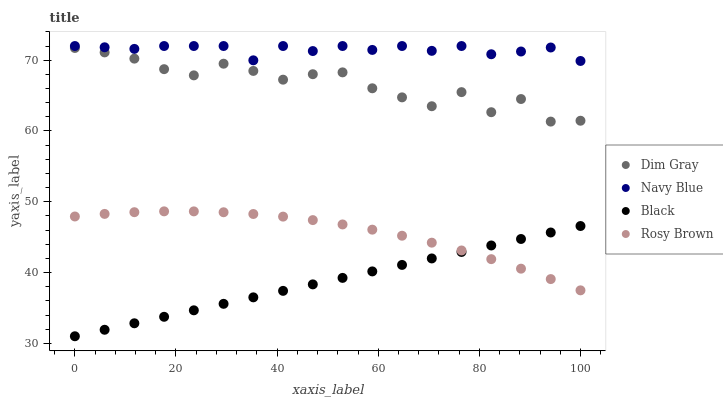Does Black have the minimum area under the curve?
Answer yes or no. Yes. Does Navy Blue have the maximum area under the curve?
Answer yes or no. Yes. Does Rosy Brown have the minimum area under the curve?
Answer yes or no. No. Does Rosy Brown have the maximum area under the curve?
Answer yes or no. No. Is Black the smoothest?
Answer yes or no. Yes. Is Dim Gray the roughest?
Answer yes or no. Yes. Is Rosy Brown the smoothest?
Answer yes or no. No. Is Rosy Brown the roughest?
Answer yes or no. No. Does Black have the lowest value?
Answer yes or no. Yes. Does Rosy Brown have the lowest value?
Answer yes or no. No. Does Navy Blue have the highest value?
Answer yes or no. Yes. Does Rosy Brown have the highest value?
Answer yes or no. No. Is Black less than Dim Gray?
Answer yes or no. Yes. Is Navy Blue greater than Dim Gray?
Answer yes or no. Yes. Does Black intersect Rosy Brown?
Answer yes or no. Yes. Is Black less than Rosy Brown?
Answer yes or no. No. Is Black greater than Rosy Brown?
Answer yes or no. No. Does Black intersect Dim Gray?
Answer yes or no. No. 